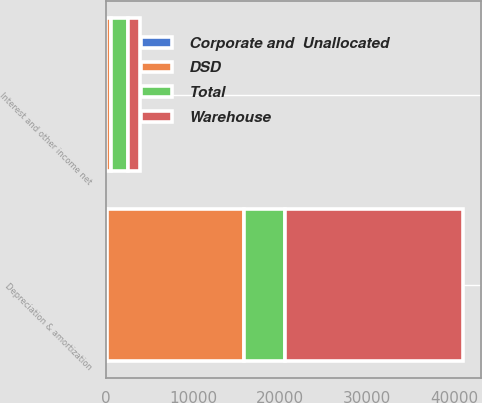Convert chart. <chart><loc_0><loc_0><loc_500><loc_500><stacked_bar_chart><ecel><fcel>Interest and other income net<fcel>Depreciation & amortization<nl><fcel>DSD<fcel>494<fcel>15660<nl><fcel>Corporate and  Unallocated<fcel>2<fcel>139<nl><fcel>Total<fcel>1961<fcel>4714<nl><fcel>Warehouse<fcel>1469<fcel>20513<nl></chart> 